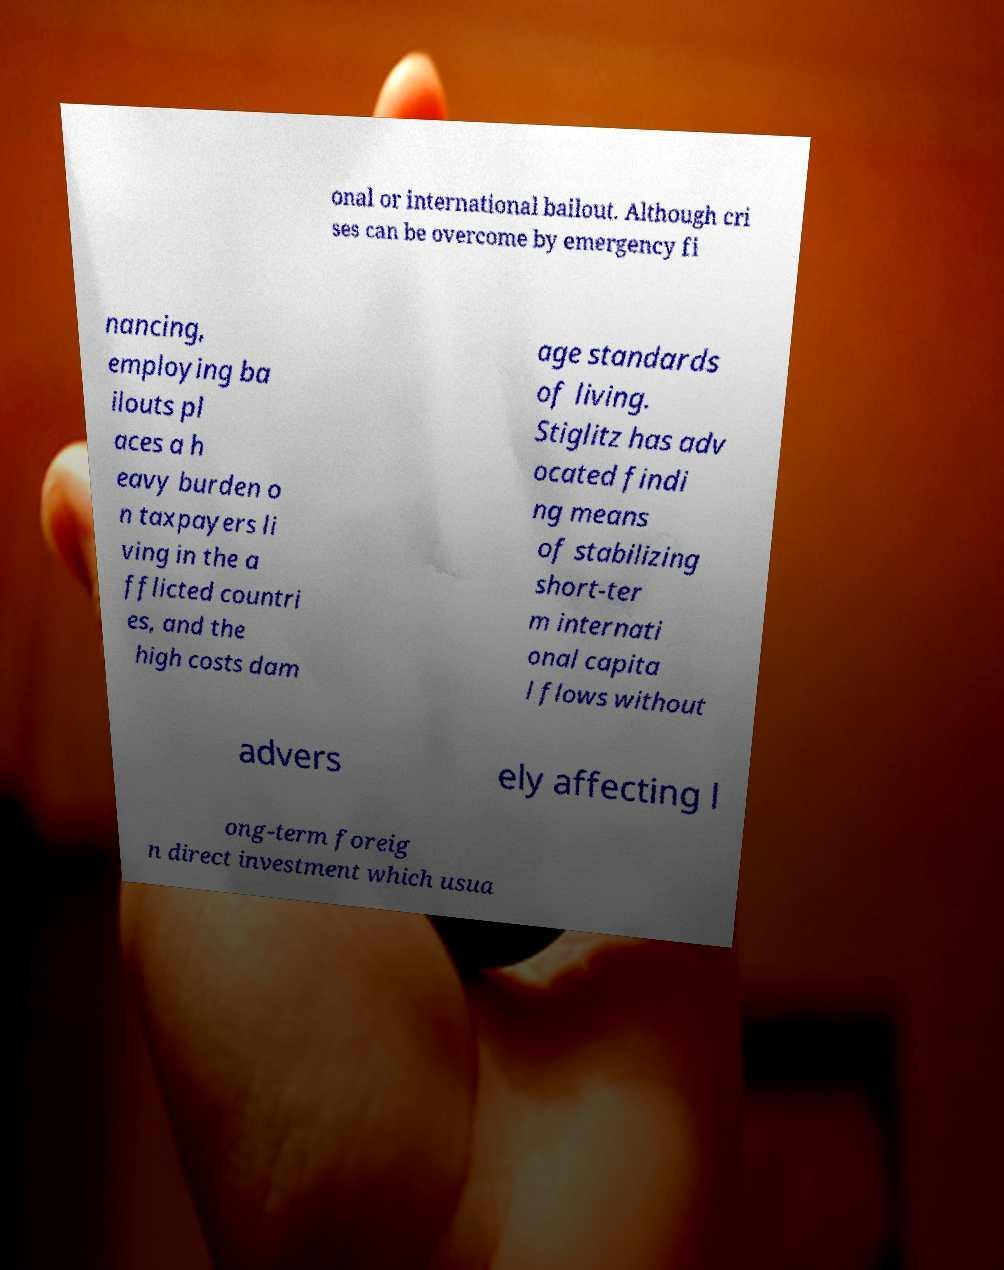Can you accurately transcribe the text from the provided image for me? onal or international bailout. Although cri ses can be overcome by emergency fi nancing, employing ba ilouts pl aces a h eavy burden o n taxpayers li ving in the a fflicted countri es, and the high costs dam age standards of living. Stiglitz has adv ocated findi ng means of stabilizing short-ter m internati onal capita l flows without advers ely affecting l ong-term foreig n direct investment which usua 